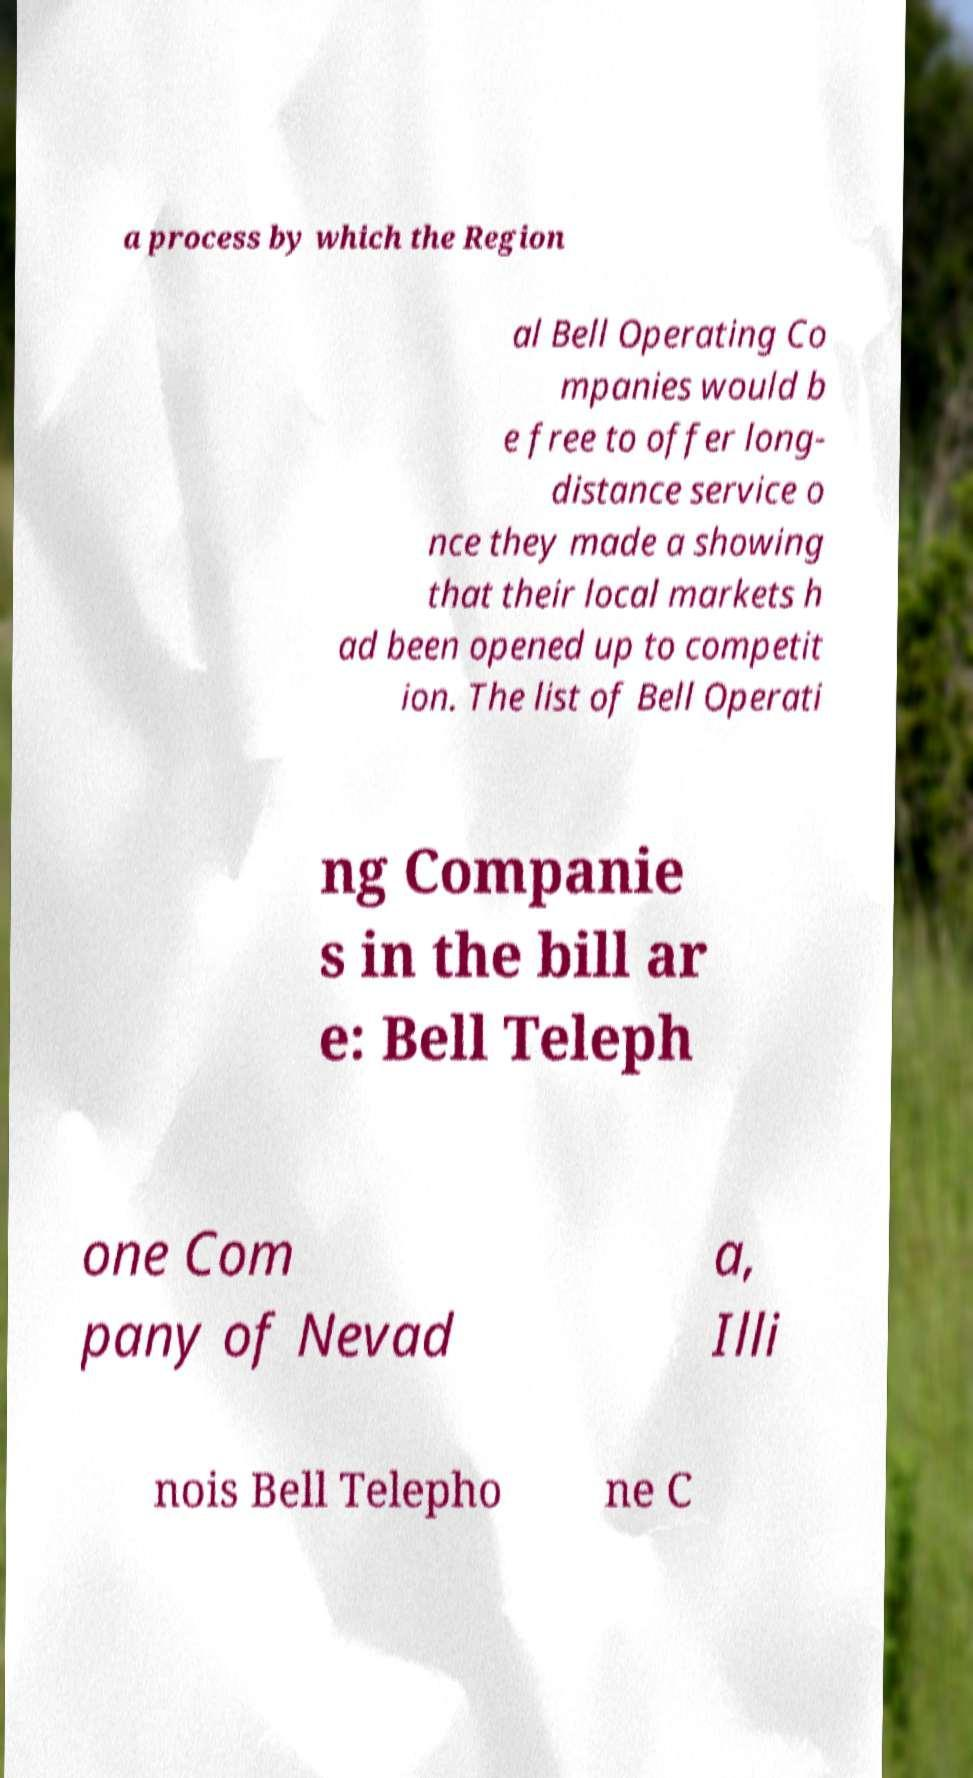Please read and relay the text visible in this image. What does it say? a process by which the Region al Bell Operating Co mpanies would b e free to offer long- distance service o nce they made a showing that their local markets h ad been opened up to competit ion. The list of Bell Operati ng Companie s in the bill ar e: Bell Teleph one Com pany of Nevad a, Illi nois Bell Telepho ne C 